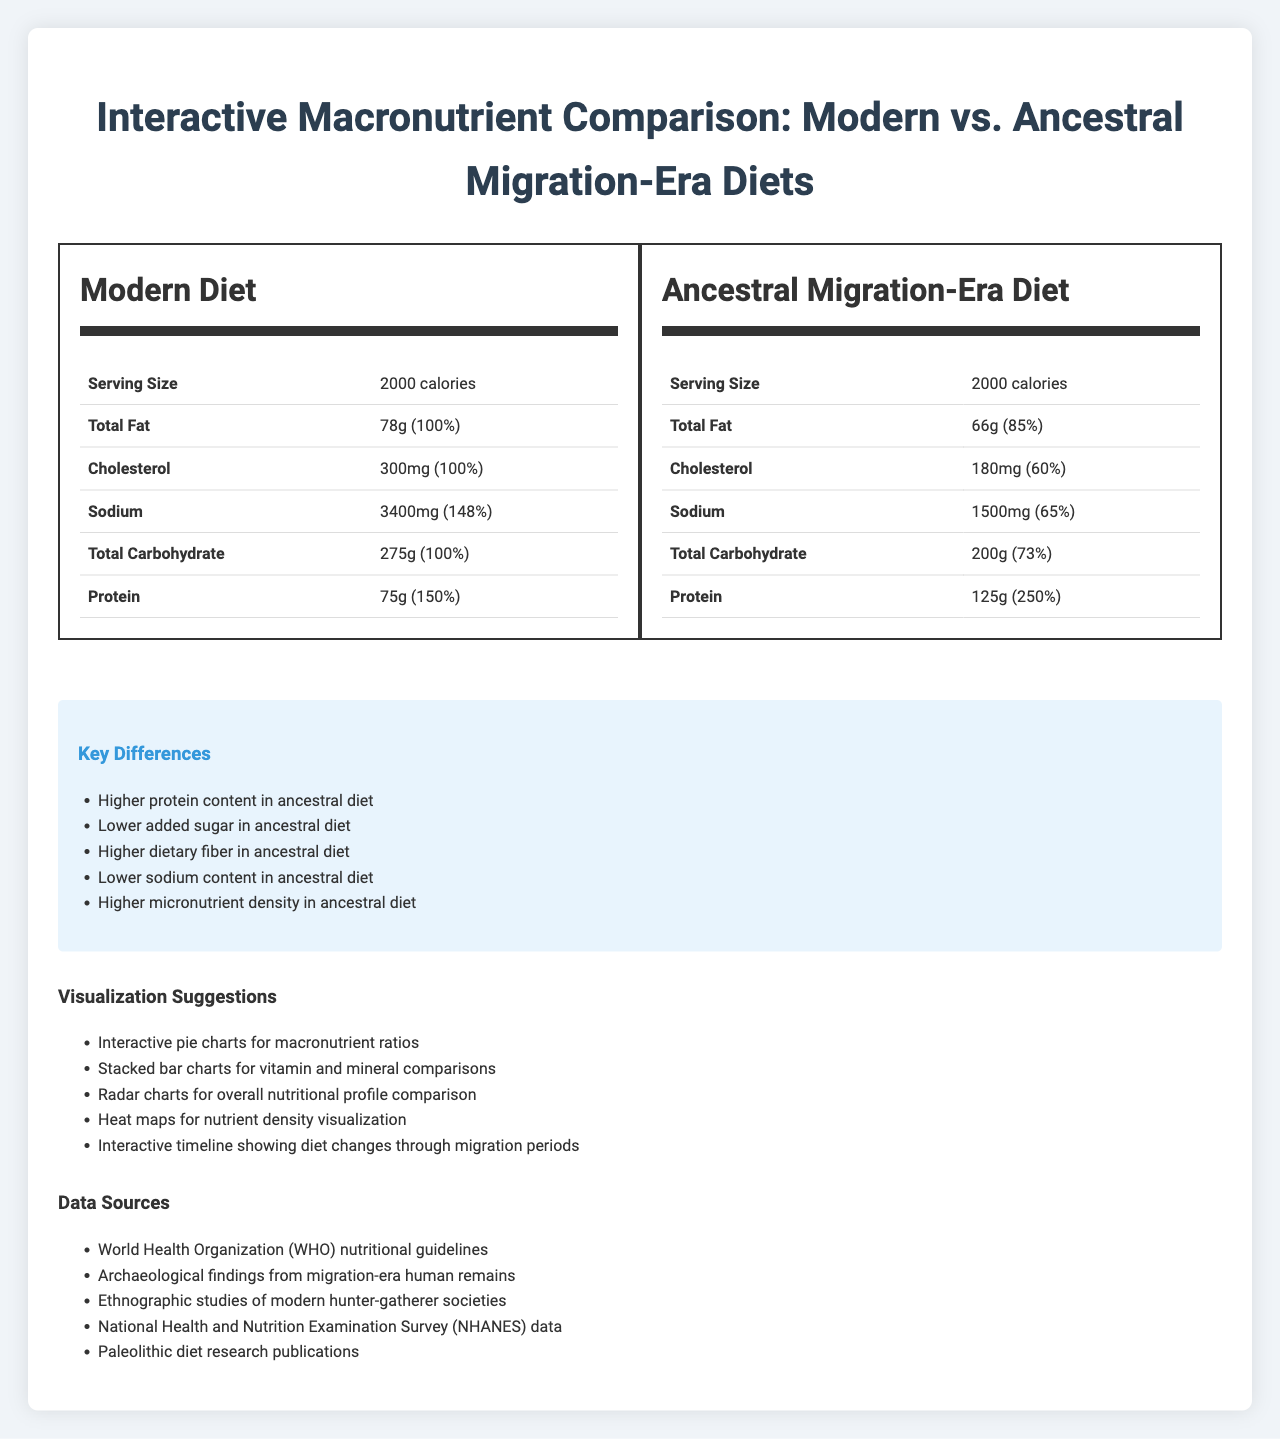what is the total fat amount in the modern diet? The document states that the "total fat" in the modern diet is "78g."
Answer: 78g What is the serving size mentioned for both diets? The serving size mentioned for both modern and ancestral diets is "2000 calories."
Answer: 2000 calories How does the cholesterol content in the modern diet compare to the ancestral diet? According to the document, the cholesterol content in the modern diet is "300mg," whereas in the ancestral diet it is "180mg."
Answer: Modern diet: 300mg, Ancestral diet: 180mg What is the added sugar content in the ancestral diet? The breakdown for "total sugars" in the ancestral diet lists "added sugars" as "0g."
Answer: 0g Which diet has a higher daily value percentage of dietary fiber? A. Modern Diet B. Ancestral Diet The ancestral diet's dietary fiber daily value percentage is "161%" compared to "89%" in the modern diet.
Answer: B. Ancestral Diet What are the five key differences between the modern and ancestral migration-era diets listed in the document? The key differences are listed in the "key differences" section.
Answer: Higher protein content in ancestral diet, Lower added sugar in ancestral diet, Higher dietary fiber in ancestral diet, Lower sodium content in ancestral diet, Higher micronutrient density in ancestral diet Which diet contains trans fat, and how much? According to the breakdown of "total fat," the modern diet contains "2g" of trans fat.
Answer: Modern diet: 2g What are the visualization suggestions provided in the document? The "visualization suggestions" section lists these five suggestions.
Answer: Interactive pie charts for macronutrient ratios, Stacked bar charts for vitamin and mineral comparisons, Radar charts for overall nutritional profile comparison, Heat maps for nutrient density visualization, Interactive timeline showing diet changes through migration periods What is the daily value percentage for protein in the modern diet? The modern diet's "total protein" daily value percentage is "150%."
Answer: 150% Is the cholesterol content in the ancestral diet higher than in the modern diet? (Yes/No) The cholesterol content is lower in the ancestral diet (180mg) compared to the modern diet (300mg).
Answer: No Which vitamins and minerals are higher in ancestral diets compared to modern diets? I. Calcium II. Iron III. Potassium The ancestral diet has higher amounts of iron (25mg vs. 18mg) and potassium (4700mg vs. 3500mg).
Answer: II. Iron and III. Potassium Describe the purpose and main contents of the document. This is a summary of the contents and purpose of the document, highlighting its comparative analysis and visualization suggestions.
Answer: The document titled "Interactive Macronutrient Comparison: Modern vs. Ancestral Migration-Era Diets" provides a detailed nutritional comparison between modern diets and those from the ancestral migration era. It compares macronutrient and micronutrient content, daily value percentages, and highlights key differences between the two diets. Additionally, it suggests visualization methods for presenting the comparative data and lists sources for the information provided. What is the main source of sodium mentioned in the document? The document provides the total sodium content but does not specify the source of sodium for either modern or ancestral diets.
Answer: Not enough information 